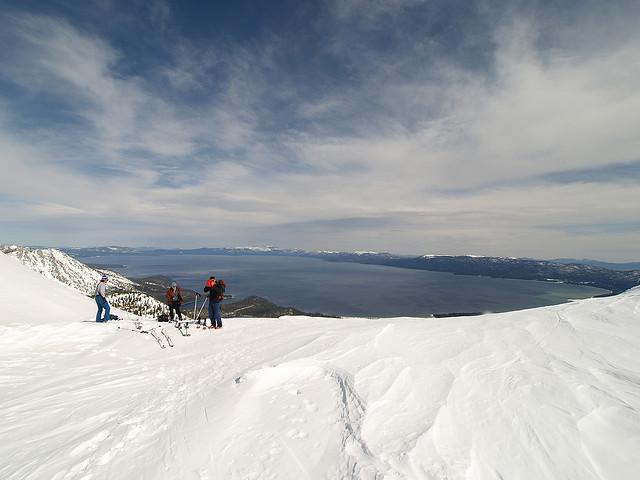Is the temperature cold?
Give a very brief answer. Yes. What are these people doing?
Keep it brief. Skiing. What color is the sky?
Be succinct. Blue. 